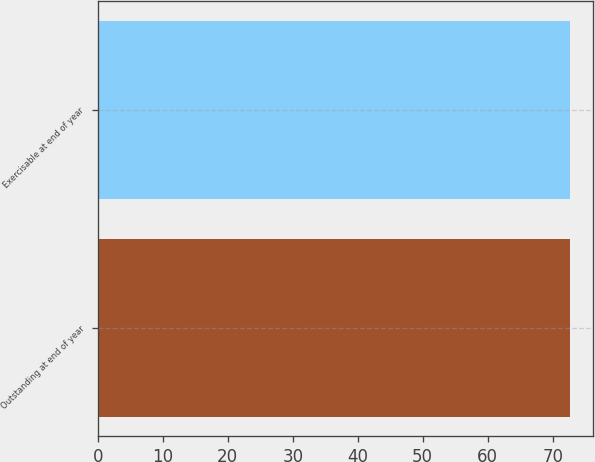Convert chart to OTSL. <chart><loc_0><loc_0><loc_500><loc_500><bar_chart><fcel>Outstanding at end of year<fcel>Exercisable at end of year<nl><fcel>72.64<fcel>72.6<nl></chart> 